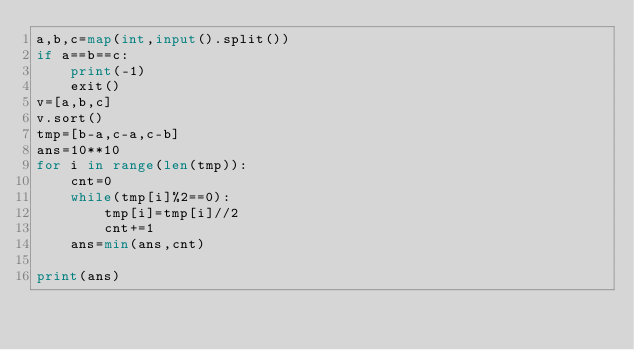<code> <loc_0><loc_0><loc_500><loc_500><_Python_>a,b,c=map(int,input().split())
if a==b==c:
    print(-1)
    exit()
v=[a,b,c]
v.sort()
tmp=[b-a,c-a,c-b]
ans=10**10
for i in range(len(tmp)):
    cnt=0
    while(tmp[i]%2==0):
        tmp[i]=tmp[i]//2
        cnt+=1
    ans=min(ans,cnt)

print(ans)
</code> 